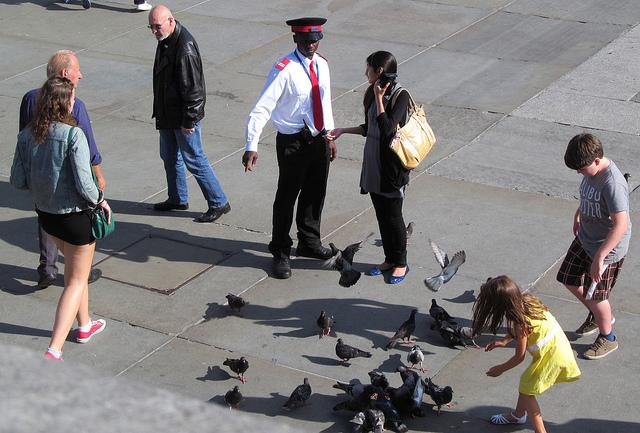What does the girl in yellow do to the birds?

Choices:
A) hide
B) grab them
C) hit them
D) feed them feed them 